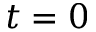<formula> <loc_0><loc_0><loc_500><loc_500>t = 0</formula> 